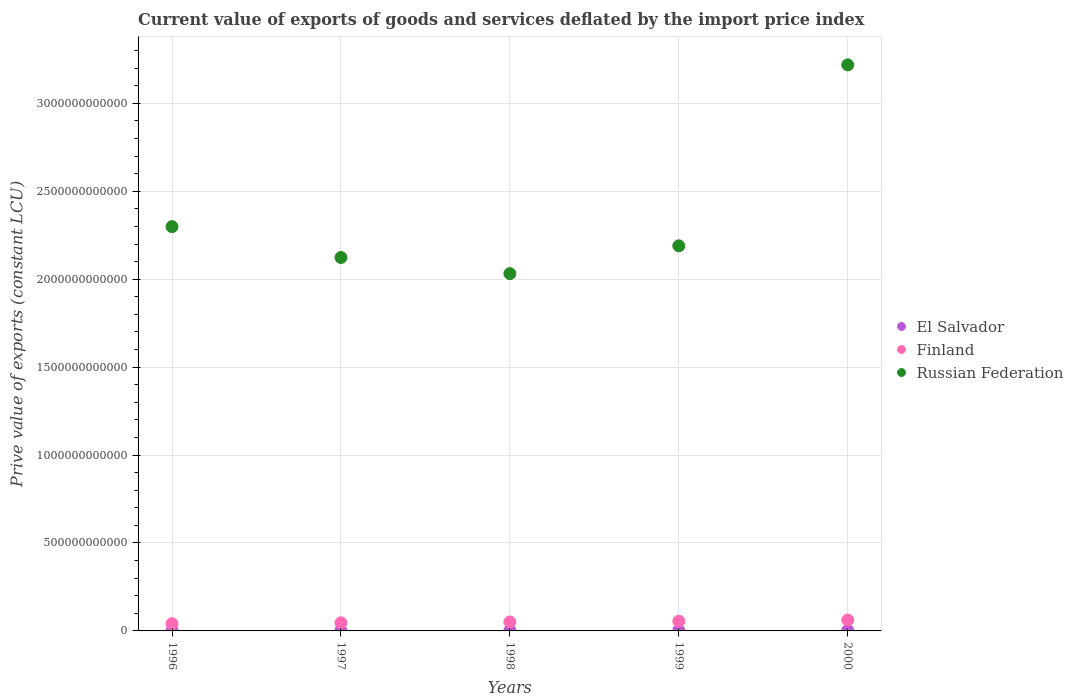How many different coloured dotlines are there?
Your response must be concise. 3. Is the number of dotlines equal to the number of legend labels?
Offer a very short reply. Yes. What is the prive value of exports in Finland in 1998?
Offer a terse response. 5.11e+1. Across all years, what is the maximum prive value of exports in El Salvador?
Ensure brevity in your answer.  2.85e+09. Across all years, what is the minimum prive value of exports in Russian Federation?
Offer a very short reply. 2.03e+12. In which year was the prive value of exports in Russian Federation maximum?
Provide a short and direct response. 2000. In which year was the prive value of exports in Russian Federation minimum?
Keep it short and to the point. 1998. What is the total prive value of exports in Finland in the graph?
Offer a very short reply. 2.55e+11. What is the difference between the prive value of exports in El Salvador in 1999 and that in 2000?
Provide a succinct answer. -2.73e+08. What is the difference between the prive value of exports in El Salvador in 2000 and the prive value of exports in Russian Federation in 1996?
Offer a very short reply. -2.30e+12. What is the average prive value of exports in Russian Federation per year?
Your answer should be very brief. 2.37e+12. In the year 1996, what is the difference between the prive value of exports in El Salvador and prive value of exports in Finland?
Offer a terse response. -3.92e+1. In how many years, is the prive value of exports in Russian Federation greater than 2100000000000 LCU?
Provide a succinct answer. 4. What is the ratio of the prive value of exports in Finland in 1996 to that in 1998?
Keep it short and to the point. 0.8. Is the prive value of exports in Russian Federation in 1997 less than that in 2000?
Provide a short and direct response. Yes. Is the difference between the prive value of exports in El Salvador in 1996 and 1997 greater than the difference between the prive value of exports in Finland in 1996 and 1997?
Provide a succinct answer. Yes. What is the difference between the highest and the second highest prive value of exports in Russian Federation?
Your response must be concise. 9.20e+11. What is the difference between the highest and the lowest prive value of exports in El Salvador?
Give a very brief answer. 1.02e+09. How many dotlines are there?
Offer a terse response. 3. How many years are there in the graph?
Ensure brevity in your answer.  5. What is the difference between two consecutive major ticks on the Y-axis?
Give a very brief answer. 5.00e+11. Are the values on the major ticks of Y-axis written in scientific E-notation?
Offer a terse response. No. Does the graph contain grids?
Your answer should be compact. Yes. How many legend labels are there?
Offer a very short reply. 3. How are the legend labels stacked?
Your answer should be compact. Vertical. What is the title of the graph?
Provide a succinct answer. Current value of exports of goods and services deflated by the import price index. What is the label or title of the X-axis?
Keep it short and to the point. Years. What is the label or title of the Y-axis?
Provide a succinct answer. Prive value of exports (constant LCU). What is the Prive value of exports (constant LCU) of El Salvador in 1996?
Your answer should be compact. 1.83e+09. What is the Prive value of exports (constant LCU) of Finland in 1996?
Ensure brevity in your answer.  4.10e+1. What is the Prive value of exports (constant LCU) of Russian Federation in 1996?
Provide a short and direct response. 2.30e+12. What is the Prive value of exports (constant LCU) in El Salvador in 1997?
Your answer should be compact. 2.37e+09. What is the Prive value of exports (constant LCU) of Finland in 1997?
Your answer should be very brief. 4.61e+1. What is the Prive value of exports (constant LCU) of Russian Federation in 1997?
Give a very brief answer. 2.12e+12. What is the Prive value of exports (constant LCU) of El Salvador in 1998?
Give a very brief answer. 2.51e+09. What is the Prive value of exports (constant LCU) in Finland in 1998?
Provide a short and direct response. 5.11e+1. What is the Prive value of exports (constant LCU) in Russian Federation in 1998?
Ensure brevity in your answer.  2.03e+12. What is the Prive value of exports (constant LCU) of El Salvador in 1999?
Your response must be concise. 2.58e+09. What is the Prive value of exports (constant LCU) of Finland in 1999?
Provide a short and direct response. 5.52e+1. What is the Prive value of exports (constant LCU) of Russian Federation in 1999?
Ensure brevity in your answer.  2.19e+12. What is the Prive value of exports (constant LCU) of El Salvador in 2000?
Give a very brief answer. 2.85e+09. What is the Prive value of exports (constant LCU) in Finland in 2000?
Your response must be concise. 6.18e+1. What is the Prive value of exports (constant LCU) in Russian Federation in 2000?
Offer a very short reply. 3.22e+12. Across all years, what is the maximum Prive value of exports (constant LCU) in El Salvador?
Provide a short and direct response. 2.85e+09. Across all years, what is the maximum Prive value of exports (constant LCU) of Finland?
Provide a short and direct response. 6.18e+1. Across all years, what is the maximum Prive value of exports (constant LCU) in Russian Federation?
Give a very brief answer. 3.22e+12. Across all years, what is the minimum Prive value of exports (constant LCU) of El Salvador?
Keep it short and to the point. 1.83e+09. Across all years, what is the minimum Prive value of exports (constant LCU) of Finland?
Provide a succinct answer. 4.10e+1. Across all years, what is the minimum Prive value of exports (constant LCU) in Russian Federation?
Ensure brevity in your answer.  2.03e+12. What is the total Prive value of exports (constant LCU) of El Salvador in the graph?
Make the answer very short. 1.21e+1. What is the total Prive value of exports (constant LCU) in Finland in the graph?
Offer a very short reply. 2.55e+11. What is the total Prive value of exports (constant LCU) in Russian Federation in the graph?
Offer a terse response. 1.19e+13. What is the difference between the Prive value of exports (constant LCU) in El Salvador in 1996 and that in 1997?
Offer a terse response. -5.42e+08. What is the difference between the Prive value of exports (constant LCU) in Finland in 1996 and that in 1997?
Give a very brief answer. -5.09e+09. What is the difference between the Prive value of exports (constant LCU) of Russian Federation in 1996 and that in 1997?
Provide a succinct answer. 1.76e+11. What is the difference between the Prive value of exports (constant LCU) of El Salvador in 1996 and that in 1998?
Ensure brevity in your answer.  -6.82e+08. What is the difference between the Prive value of exports (constant LCU) in Finland in 1996 and that in 1998?
Give a very brief answer. -1.01e+1. What is the difference between the Prive value of exports (constant LCU) of Russian Federation in 1996 and that in 1998?
Your response must be concise. 2.67e+11. What is the difference between the Prive value of exports (constant LCU) of El Salvador in 1996 and that in 1999?
Your answer should be compact. -7.51e+08. What is the difference between the Prive value of exports (constant LCU) of Finland in 1996 and that in 1999?
Provide a succinct answer. -1.42e+1. What is the difference between the Prive value of exports (constant LCU) of Russian Federation in 1996 and that in 1999?
Offer a very short reply. 1.09e+11. What is the difference between the Prive value of exports (constant LCU) of El Salvador in 1996 and that in 2000?
Your response must be concise. -1.02e+09. What is the difference between the Prive value of exports (constant LCU) in Finland in 1996 and that in 2000?
Make the answer very short. -2.07e+1. What is the difference between the Prive value of exports (constant LCU) of Russian Federation in 1996 and that in 2000?
Offer a terse response. -9.20e+11. What is the difference between the Prive value of exports (constant LCU) of El Salvador in 1997 and that in 1998?
Keep it short and to the point. -1.39e+08. What is the difference between the Prive value of exports (constant LCU) of Finland in 1997 and that in 1998?
Offer a terse response. -5.00e+09. What is the difference between the Prive value of exports (constant LCU) in Russian Federation in 1997 and that in 1998?
Offer a terse response. 9.16e+1. What is the difference between the Prive value of exports (constant LCU) of El Salvador in 1997 and that in 1999?
Ensure brevity in your answer.  -2.09e+08. What is the difference between the Prive value of exports (constant LCU) in Finland in 1997 and that in 1999?
Offer a terse response. -9.09e+09. What is the difference between the Prive value of exports (constant LCU) in Russian Federation in 1997 and that in 1999?
Offer a very short reply. -6.64e+1. What is the difference between the Prive value of exports (constant LCU) of El Salvador in 1997 and that in 2000?
Your answer should be very brief. -4.82e+08. What is the difference between the Prive value of exports (constant LCU) in Finland in 1997 and that in 2000?
Your answer should be very brief. -1.56e+1. What is the difference between the Prive value of exports (constant LCU) in Russian Federation in 1997 and that in 2000?
Your answer should be compact. -1.10e+12. What is the difference between the Prive value of exports (constant LCU) of El Salvador in 1998 and that in 1999?
Keep it short and to the point. -6.94e+07. What is the difference between the Prive value of exports (constant LCU) in Finland in 1998 and that in 1999?
Make the answer very short. -4.10e+09. What is the difference between the Prive value of exports (constant LCU) in Russian Federation in 1998 and that in 1999?
Offer a terse response. -1.58e+11. What is the difference between the Prive value of exports (constant LCU) in El Salvador in 1998 and that in 2000?
Offer a terse response. -3.42e+08. What is the difference between the Prive value of exports (constant LCU) of Finland in 1998 and that in 2000?
Your answer should be compact. -1.07e+1. What is the difference between the Prive value of exports (constant LCU) in Russian Federation in 1998 and that in 2000?
Your answer should be very brief. -1.19e+12. What is the difference between the Prive value of exports (constant LCU) in El Salvador in 1999 and that in 2000?
Your response must be concise. -2.73e+08. What is the difference between the Prive value of exports (constant LCU) of Finland in 1999 and that in 2000?
Your response must be concise. -6.55e+09. What is the difference between the Prive value of exports (constant LCU) in Russian Federation in 1999 and that in 2000?
Offer a terse response. -1.03e+12. What is the difference between the Prive value of exports (constant LCU) of El Salvador in 1996 and the Prive value of exports (constant LCU) of Finland in 1997?
Ensure brevity in your answer.  -4.43e+1. What is the difference between the Prive value of exports (constant LCU) of El Salvador in 1996 and the Prive value of exports (constant LCU) of Russian Federation in 1997?
Give a very brief answer. -2.12e+12. What is the difference between the Prive value of exports (constant LCU) of Finland in 1996 and the Prive value of exports (constant LCU) of Russian Federation in 1997?
Provide a succinct answer. -2.08e+12. What is the difference between the Prive value of exports (constant LCU) in El Salvador in 1996 and the Prive value of exports (constant LCU) in Finland in 1998?
Offer a terse response. -4.93e+1. What is the difference between the Prive value of exports (constant LCU) of El Salvador in 1996 and the Prive value of exports (constant LCU) of Russian Federation in 1998?
Ensure brevity in your answer.  -2.03e+12. What is the difference between the Prive value of exports (constant LCU) of Finland in 1996 and the Prive value of exports (constant LCU) of Russian Federation in 1998?
Make the answer very short. -1.99e+12. What is the difference between the Prive value of exports (constant LCU) of El Salvador in 1996 and the Prive value of exports (constant LCU) of Finland in 1999?
Offer a very short reply. -5.34e+1. What is the difference between the Prive value of exports (constant LCU) of El Salvador in 1996 and the Prive value of exports (constant LCU) of Russian Federation in 1999?
Make the answer very short. -2.19e+12. What is the difference between the Prive value of exports (constant LCU) in Finland in 1996 and the Prive value of exports (constant LCU) in Russian Federation in 1999?
Your answer should be very brief. -2.15e+12. What is the difference between the Prive value of exports (constant LCU) in El Salvador in 1996 and the Prive value of exports (constant LCU) in Finland in 2000?
Offer a very short reply. -5.99e+1. What is the difference between the Prive value of exports (constant LCU) of El Salvador in 1996 and the Prive value of exports (constant LCU) of Russian Federation in 2000?
Offer a very short reply. -3.22e+12. What is the difference between the Prive value of exports (constant LCU) in Finland in 1996 and the Prive value of exports (constant LCU) in Russian Federation in 2000?
Keep it short and to the point. -3.18e+12. What is the difference between the Prive value of exports (constant LCU) of El Salvador in 1997 and the Prive value of exports (constant LCU) of Finland in 1998?
Your answer should be very brief. -4.88e+1. What is the difference between the Prive value of exports (constant LCU) of El Salvador in 1997 and the Prive value of exports (constant LCU) of Russian Federation in 1998?
Give a very brief answer. -2.03e+12. What is the difference between the Prive value of exports (constant LCU) of Finland in 1997 and the Prive value of exports (constant LCU) of Russian Federation in 1998?
Provide a short and direct response. -1.99e+12. What is the difference between the Prive value of exports (constant LCU) of El Salvador in 1997 and the Prive value of exports (constant LCU) of Finland in 1999?
Give a very brief answer. -5.29e+1. What is the difference between the Prive value of exports (constant LCU) of El Salvador in 1997 and the Prive value of exports (constant LCU) of Russian Federation in 1999?
Make the answer very short. -2.19e+12. What is the difference between the Prive value of exports (constant LCU) in Finland in 1997 and the Prive value of exports (constant LCU) in Russian Federation in 1999?
Give a very brief answer. -2.14e+12. What is the difference between the Prive value of exports (constant LCU) in El Salvador in 1997 and the Prive value of exports (constant LCU) in Finland in 2000?
Your response must be concise. -5.94e+1. What is the difference between the Prive value of exports (constant LCU) in El Salvador in 1997 and the Prive value of exports (constant LCU) in Russian Federation in 2000?
Provide a succinct answer. -3.22e+12. What is the difference between the Prive value of exports (constant LCU) of Finland in 1997 and the Prive value of exports (constant LCU) of Russian Federation in 2000?
Make the answer very short. -3.17e+12. What is the difference between the Prive value of exports (constant LCU) in El Salvador in 1998 and the Prive value of exports (constant LCU) in Finland in 1999?
Your answer should be very brief. -5.27e+1. What is the difference between the Prive value of exports (constant LCU) of El Salvador in 1998 and the Prive value of exports (constant LCU) of Russian Federation in 1999?
Give a very brief answer. -2.19e+12. What is the difference between the Prive value of exports (constant LCU) of Finland in 1998 and the Prive value of exports (constant LCU) of Russian Federation in 1999?
Your answer should be very brief. -2.14e+12. What is the difference between the Prive value of exports (constant LCU) in El Salvador in 1998 and the Prive value of exports (constant LCU) in Finland in 2000?
Your answer should be very brief. -5.93e+1. What is the difference between the Prive value of exports (constant LCU) of El Salvador in 1998 and the Prive value of exports (constant LCU) of Russian Federation in 2000?
Your answer should be compact. -3.22e+12. What is the difference between the Prive value of exports (constant LCU) of Finland in 1998 and the Prive value of exports (constant LCU) of Russian Federation in 2000?
Your response must be concise. -3.17e+12. What is the difference between the Prive value of exports (constant LCU) of El Salvador in 1999 and the Prive value of exports (constant LCU) of Finland in 2000?
Your answer should be compact. -5.92e+1. What is the difference between the Prive value of exports (constant LCU) of El Salvador in 1999 and the Prive value of exports (constant LCU) of Russian Federation in 2000?
Provide a short and direct response. -3.22e+12. What is the difference between the Prive value of exports (constant LCU) in Finland in 1999 and the Prive value of exports (constant LCU) in Russian Federation in 2000?
Offer a terse response. -3.16e+12. What is the average Prive value of exports (constant LCU) of El Salvador per year?
Your answer should be compact. 2.43e+09. What is the average Prive value of exports (constant LCU) of Finland per year?
Your answer should be very brief. 5.11e+1. What is the average Prive value of exports (constant LCU) in Russian Federation per year?
Ensure brevity in your answer.  2.37e+12. In the year 1996, what is the difference between the Prive value of exports (constant LCU) in El Salvador and Prive value of exports (constant LCU) in Finland?
Offer a very short reply. -3.92e+1. In the year 1996, what is the difference between the Prive value of exports (constant LCU) of El Salvador and Prive value of exports (constant LCU) of Russian Federation?
Ensure brevity in your answer.  -2.30e+12. In the year 1996, what is the difference between the Prive value of exports (constant LCU) of Finland and Prive value of exports (constant LCU) of Russian Federation?
Ensure brevity in your answer.  -2.26e+12. In the year 1997, what is the difference between the Prive value of exports (constant LCU) in El Salvador and Prive value of exports (constant LCU) in Finland?
Offer a terse response. -4.38e+1. In the year 1997, what is the difference between the Prive value of exports (constant LCU) of El Salvador and Prive value of exports (constant LCU) of Russian Federation?
Your answer should be compact. -2.12e+12. In the year 1997, what is the difference between the Prive value of exports (constant LCU) in Finland and Prive value of exports (constant LCU) in Russian Federation?
Give a very brief answer. -2.08e+12. In the year 1998, what is the difference between the Prive value of exports (constant LCU) of El Salvador and Prive value of exports (constant LCU) of Finland?
Provide a succinct answer. -4.86e+1. In the year 1998, what is the difference between the Prive value of exports (constant LCU) in El Salvador and Prive value of exports (constant LCU) in Russian Federation?
Provide a succinct answer. -2.03e+12. In the year 1998, what is the difference between the Prive value of exports (constant LCU) in Finland and Prive value of exports (constant LCU) in Russian Federation?
Offer a terse response. -1.98e+12. In the year 1999, what is the difference between the Prive value of exports (constant LCU) in El Salvador and Prive value of exports (constant LCU) in Finland?
Give a very brief answer. -5.26e+1. In the year 1999, what is the difference between the Prive value of exports (constant LCU) in El Salvador and Prive value of exports (constant LCU) in Russian Federation?
Make the answer very short. -2.19e+12. In the year 1999, what is the difference between the Prive value of exports (constant LCU) in Finland and Prive value of exports (constant LCU) in Russian Federation?
Give a very brief answer. -2.13e+12. In the year 2000, what is the difference between the Prive value of exports (constant LCU) in El Salvador and Prive value of exports (constant LCU) in Finland?
Give a very brief answer. -5.89e+1. In the year 2000, what is the difference between the Prive value of exports (constant LCU) of El Salvador and Prive value of exports (constant LCU) of Russian Federation?
Your answer should be compact. -3.22e+12. In the year 2000, what is the difference between the Prive value of exports (constant LCU) in Finland and Prive value of exports (constant LCU) in Russian Federation?
Provide a succinct answer. -3.16e+12. What is the ratio of the Prive value of exports (constant LCU) of El Salvador in 1996 to that in 1997?
Your answer should be very brief. 0.77. What is the ratio of the Prive value of exports (constant LCU) in Finland in 1996 to that in 1997?
Ensure brevity in your answer.  0.89. What is the ratio of the Prive value of exports (constant LCU) in Russian Federation in 1996 to that in 1997?
Your answer should be very brief. 1.08. What is the ratio of the Prive value of exports (constant LCU) of El Salvador in 1996 to that in 1998?
Make the answer very short. 0.73. What is the ratio of the Prive value of exports (constant LCU) in Finland in 1996 to that in 1998?
Provide a short and direct response. 0.8. What is the ratio of the Prive value of exports (constant LCU) of Russian Federation in 1996 to that in 1998?
Keep it short and to the point. 1.13. What is the ratio of the Prive value of exports (constant LCU) of El Salvador in 1996 to that in 1999?
Give a very brief answer. 0.71. What is the ratio of the Prive value of exports (constant LCU) in Finland in 1996 to that in 1999?
Your answer should be very brief. 0.74. What is the ratio of the Prive value of exports (constant LCU) in Russian Federation in 1996 to that in 1999?
Ensure brevity in your answer.  1.05. What is the ratio of the Prive value of exports (constant LCU) in El Salvador in 1996 to that in 2000?
Make the answer very short. 0.64. What is the ratio of the Prive value of exports (constant LCU) of Finland in 1996 to that in 2000?
Your response must be concise. 0.66. What is the ratio of the Prive value of exports (constant LCU) of Russian Federation in 1996 to that in 2000?
Provide a succinct answer. 0.71. What is the ratio of the Prive value of exports (constant LCU) of El Salvador in 1997 to that in 1998?
Your answer should be very brief. 0.94. What is the ratio of the Prive value of exports (constant LCU) in Finland in 1997 to that in 1998?
Offer a very short reply. 0.9. What is the ratio of the Prive value of exports (constant LCU) of Russian Federation in 1997 to that in 1998?
Keep it short and to the point. 1.05. What is the ratio of the Prive value of exports (constant LCU) in El Salvador in 1997 to that in 1999?
Ensure brevity in your answer.  0.92. What is the ratio of the Prive value of exports (constant LCU) in Finland in 1997 to that in 1999?
Provide a short and direct response. 0.84. What is the ratio of the Prive value of exports (constant LCU) of Russian Federation in 1997 to that in 1999?
Offer a terse response. 0.97. What is the ratio of the Prive value of exports (constant LCU) in El Salvador in 1997 to that in 2000?
Your answer should be compact. 0.83. What is the ratio of the Prive value of exports (constant LCU) in Finland in 1997 to that in 2000?
Offer a very short reply. 0.75. What is the ratio of the Prive value of exports (constant LCU) in Russian Federation in 1997 to that in 2000?
Offer a very short reply. 0.66. What is the ratio of the Prive value of exports (constant LCU) in El Salvador in 1998 to that in 1999?
Your answer should be very brief. 0.97. What is the ratio of the Prive value of exports (constant LCU) of Finland in 1998 to that in 1999?
Offer a very short reply. 0.93. What is the ratio of the Prive value of exports (constant LCU) in Russian Federation in 1998 to that in 1999?
Give a very brief answer. 0.93. What is the ratio of the Prive value of exports (constant LCU) in Finland in 1998 to that in 2000?
Your answer should be very brief. 0.83. What is the ratio of the Prive value of exports (constant LCU) of Russian Federation in 1998 to that in 2000?
Provide a short and direct response. 0.63. What is the ratio of the Prive value of exports (constant LCU) of El Salvador in 1999 to that in 2000?
Keep it short and to the point. 0.9. What is the ratio of the Prive value of exports (constant LCU) of Finland in 1999 to that in 2000?
Offer a terse response. 0.89. What is the ratio of the Prive value of exports (constant LCU) in Russian Federation in 1999 to that in 2000?
Your answer should be compact. 0.68. What is the difference between the highest and the second highest Prive value of exports (constant LCU) in El Salvador?
Offer a terse response. 2.73e+08. What is the difference between the highest and the second highest Prive value of exports (constant LCU) in Finland?
Your response must be concise. 6.55e+09. What is the difference between the highest and the second highest Prive value of exports (constant LCU) of Russian Federation?
Provide a short and direct response. 9.20e+11. What is the difference between the highest and the lowest Prive value of exports (constant LCU) of El Salvador?
Offer a very short reply. 1.02e+09. What is the difference between the highest and the lowest Prive value of exports (constant LCU) in Finland?
Keep it short and to the point. 2.07e+1. What is the difference between the highest and the lowest Prive value of exports (constant LCU) in Russian Federation?
Your answer should be very brief. 1.19e+12. 